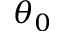<formula> <loc_0><loc_0><loc_500><loc_500>\theta _ { 0 }</formula> 